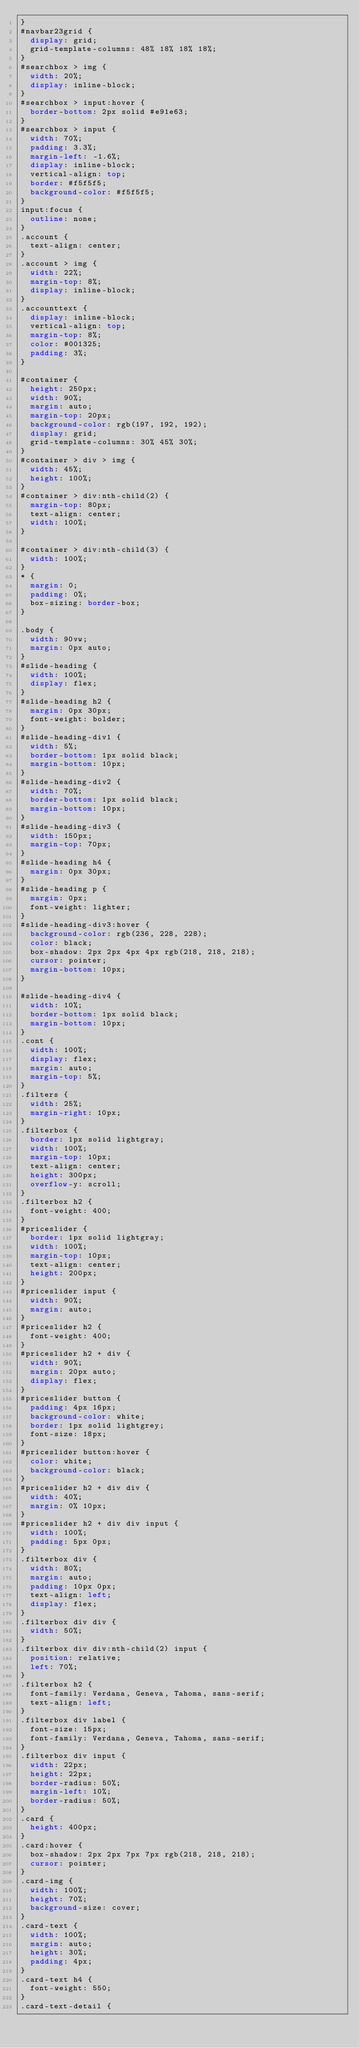Convert code to text. <code><loc_0><loc_0><loc_500><loc_500><_CSS_>}
#navbar23grid {
  display: grid;
  grid-template-columns: 48% 18% 18% 18%;
}
#searchbox > img {
  width: 20%;
  display: inline-block;
}
#searchbox > input:hover {
  border-bottom: 2px solid #e91e63;
}
#searchbox > input {
  width: 70%;
  padding: 3.3%;
  margin-left: -1.6%;
  display: inline-block;
  vertical-align: top;
  border: #f5f5f5;
  background-color: #f5f5f5;
}
input:focus {
  outline: none;
}
.account {
  text-align: center;
}
.account > img {
  width: 22%;
  margin-top: 8%;
  display: inline-block;
}
.accounttext {
  display: inline-block;
  vertical-align: top;
  margin-top: 8%;
  color: #001325;
  padding: 3%;
}

#container {
  height: 250px;
  width: 90%;
  margin: auto;
  margin-top: 20px;
  background-color: rgb(197, 192, 192);
  display: grid;
  grid-template-columns: 30% 45% 30%;
}
#container > div > img {
  width: 45%;
  height: 100%;
}
#container > div:nth-child(2) {
  margin-top: 80px;
  text-align: center;
  width: 100%;
}

#container > div:nth-child(3) {
  width: 100%;
}
* {
  margin: 0;
  padding: 0%;
  box-sizing: border-box;
}

.body {
  width: 90vw;
  margin: 0px auto;
}
#slide-heading {
  width: 100%;
  display: flex;
}
#slide-heading h2 {
  margin: 0px 30px;
  font-weight: bolder;
}
#slide-heading-div1 {
  width: 5%;
  border-bottom: 1px solid black;
  margin-bottom: 10px;
}
#slide-heading-div2 {
  width: 70%;
  border-bottom: 1px solid black;
  margin-bottom: 10px;
}
#slide-heading-div3 {
  width: 150px;
  margin-top: 70px;
}
#slide-heading h4 {
  margin: 0px 30px;
}
#slide-heading p {
  margin: 0px;
  font-weight: lighter;
}
#slide-heading-div3:hover {
  background-color: rgb(236, 228, 228);
  color: black;
  box-shadow: 2px 2px 4px 4px rgb(218, 218, 218);
  cursor: pointer;
  margin-bottom: 10px;
}

#slide-heading-div4 {
  width: 10%;
  border-bottom: 1px solid black;
  margin-bottom: 10px;
}
.cont {
  width: 100%;
  display: flex;
  margin: auto;
  margin-top: 5%;
}
.filters {
  width: 25%;
  margin-right: 10px;
}
.filterbox {
  border: 1px solid lightgray;
  width: 100%;
  margin-top: 10px;
  text-align: center;
  height: 300px;
  overflow-y: scroll;
}
.filterbox h2 {
  font-weight: 400;
}
#priceslider {
  border: 1px solid lightgray;
  width: 100%;
  margin-top: 10px;
  text-align: center;
  height: 200px;
}
#priceslider input {
  width: 90%;
  margin: auto;
}
#priceslider h2 {
  font-weight: 400;
}
#priceslider h2 + div {
  width: 90%;
  margin: 20px auto;
  display: flex;
}
#priceslider button {
  padding: 4px 16px;
  background-color: white;
  border: 1px solid lightgrey;
  font-size: 18px;
}
#priceslider button:hover {
  color: white;
  background-color: black;
}
#priceslider h2 + div div {
  width: 40%;
  margin: 0% 10px;
}
#priceslider h2 + div div input {
  width: 100%;
  padding: 5px 0px;
}
.filterbox div {
  width: 80%;
  margin: auto;
  padding: 10px 0px;
  text-align: left;
  display: flex;
}
.filterbox div div {
  width: 50%;
}
.filterbox div div:nth-child(2) input {
  position: relative;
  left: 70%;
}
.filterbox h2 {
  font-family: Verdana, Geneva, Tahoma, sans-serif;
  text-align: left;
}
.filterbox div label {
  font-size: 15px;
  font-family: Verdana, Geneva, Tahoma, sans-serif;
}
.filterbox div input {
  width: 22px;
  height: 22px;
  border-radius: 50%;
  margin-left: 10%;
  border-radius: 50%;
}
.card {
  height: 400px;
}
.card:hover {
  box-shadow: 2px 2px 7px 7px rgb(218, 218, 218);
  cursor: pointer;
}
.card-img {
  width: 100%;
  height: 70%;
  background-size: cover;
}
.card-text {
  width: 100%;
  margin: auto;
  height: 30%;
  padding: 4px;
}
.card-text h4 {
  font-weight: 550;
}
.card-text-detail {</code> 